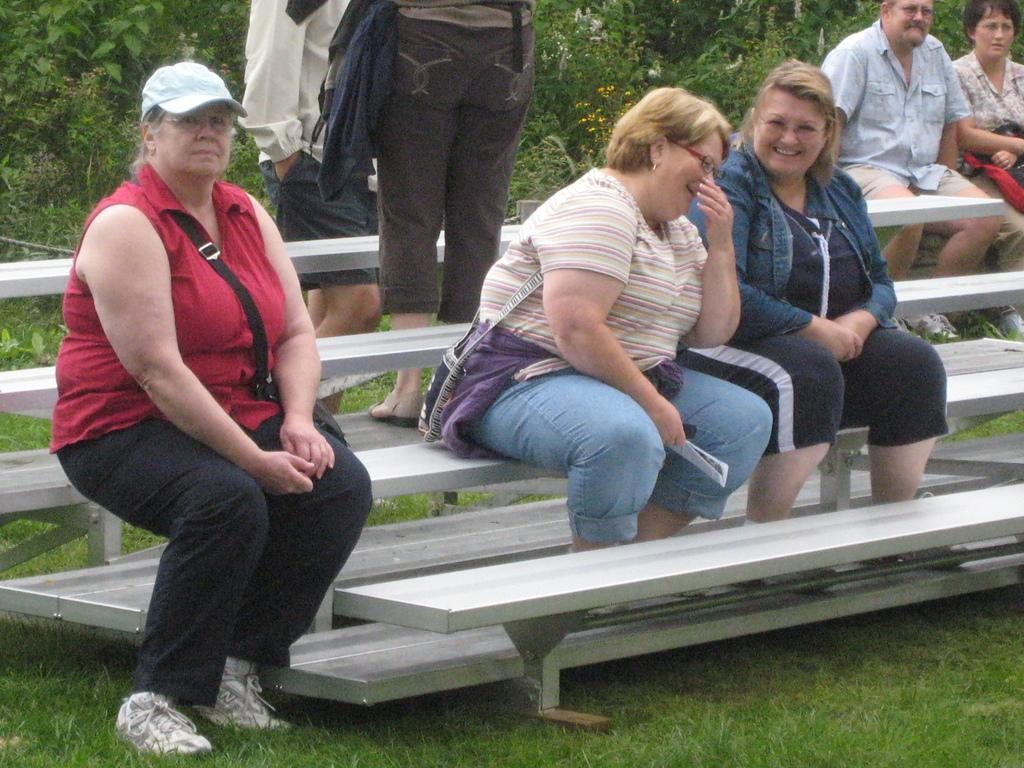How many women are in the image? There are three women in the center of the image. What are the women doing in the image? The women are sitting on a bench and smiling. What can be seen in the background of the image? There is a tree, plants, grass, and persons sitting and standing in the background of the image. What type of print can be seen on the edge of the bench? There is no print visible on the edge of the bench in the image. 